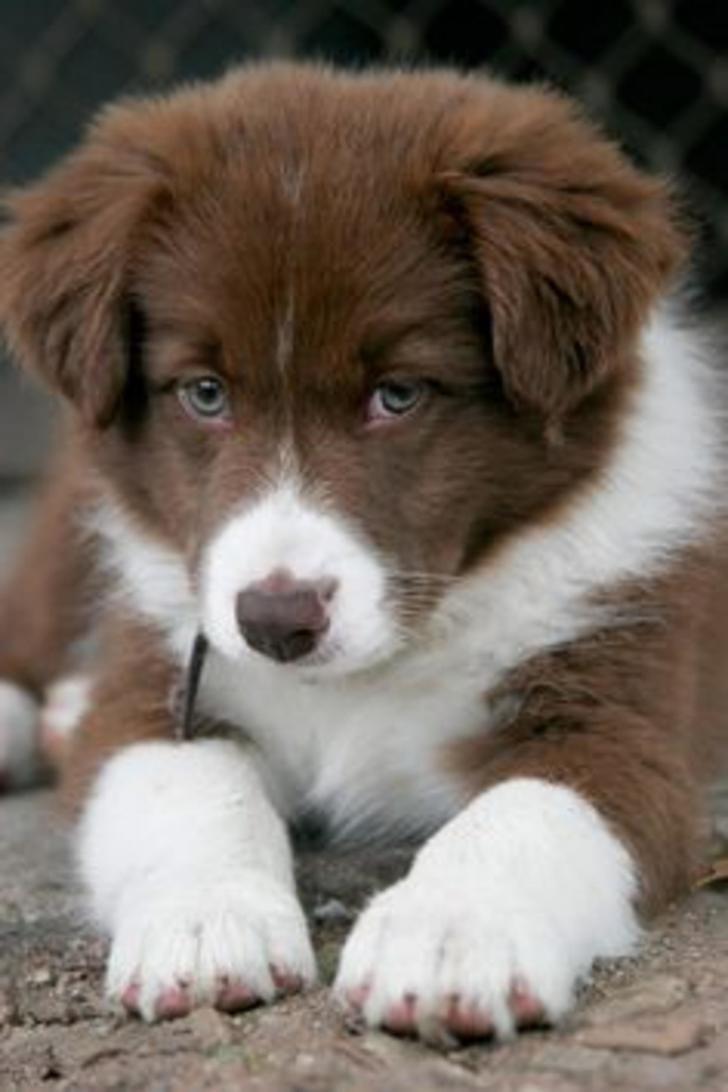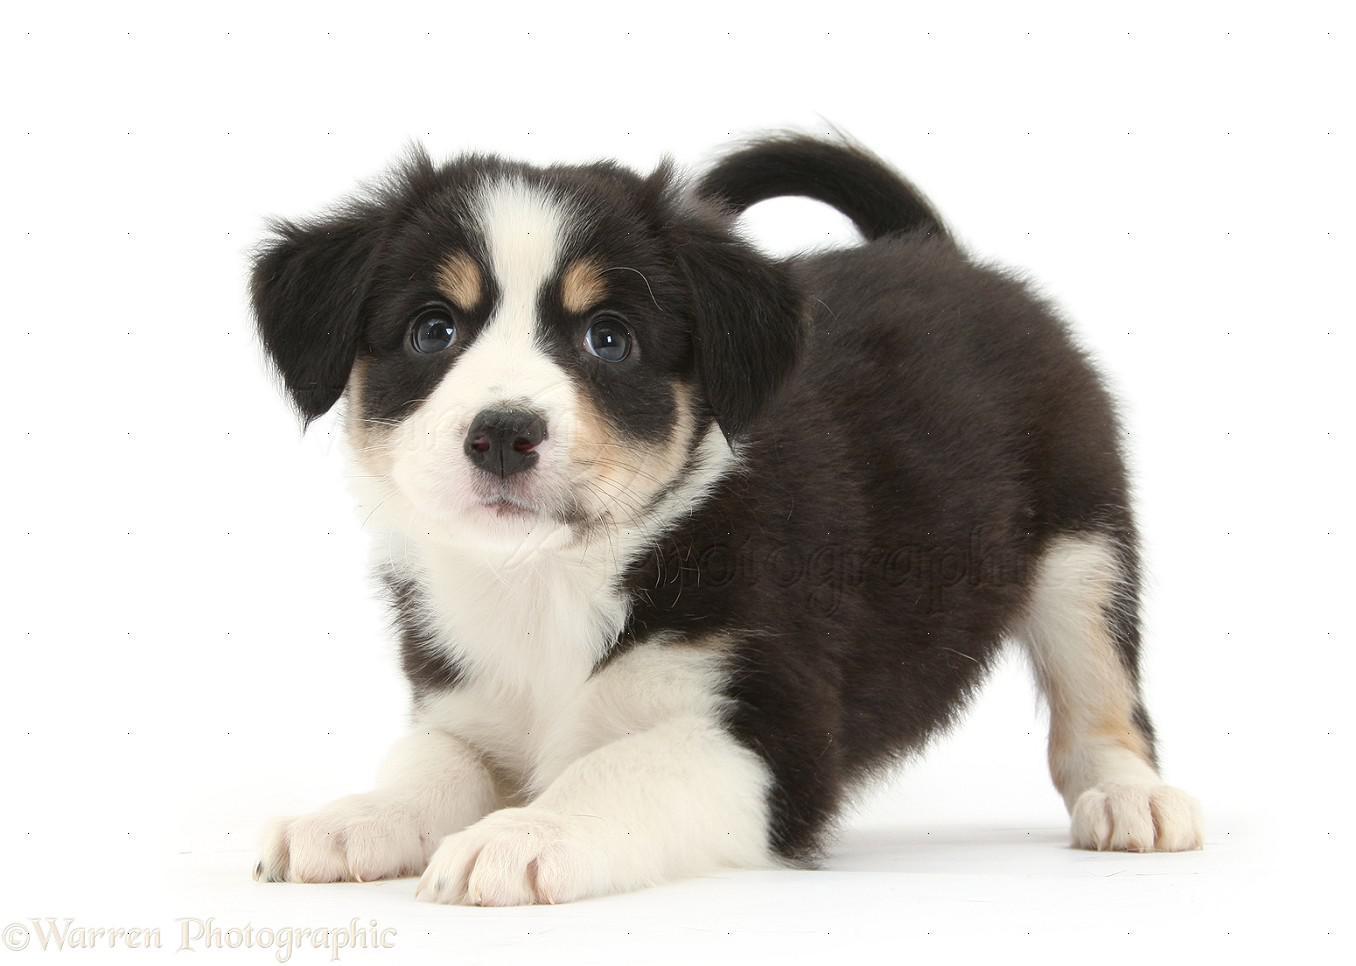The first image is the image on the left, the second image is the image on the right. For the images shown, is this caption "No more than four dogs can be seen." true? Answer yes or no. Yes. The first image is the image on the left, the second image is the image on the right. For the images displayed, is the sentence "Each image contains the same number of puppies, and all images have plain white backgrounds." factually correct? Answer yes or no. No. 